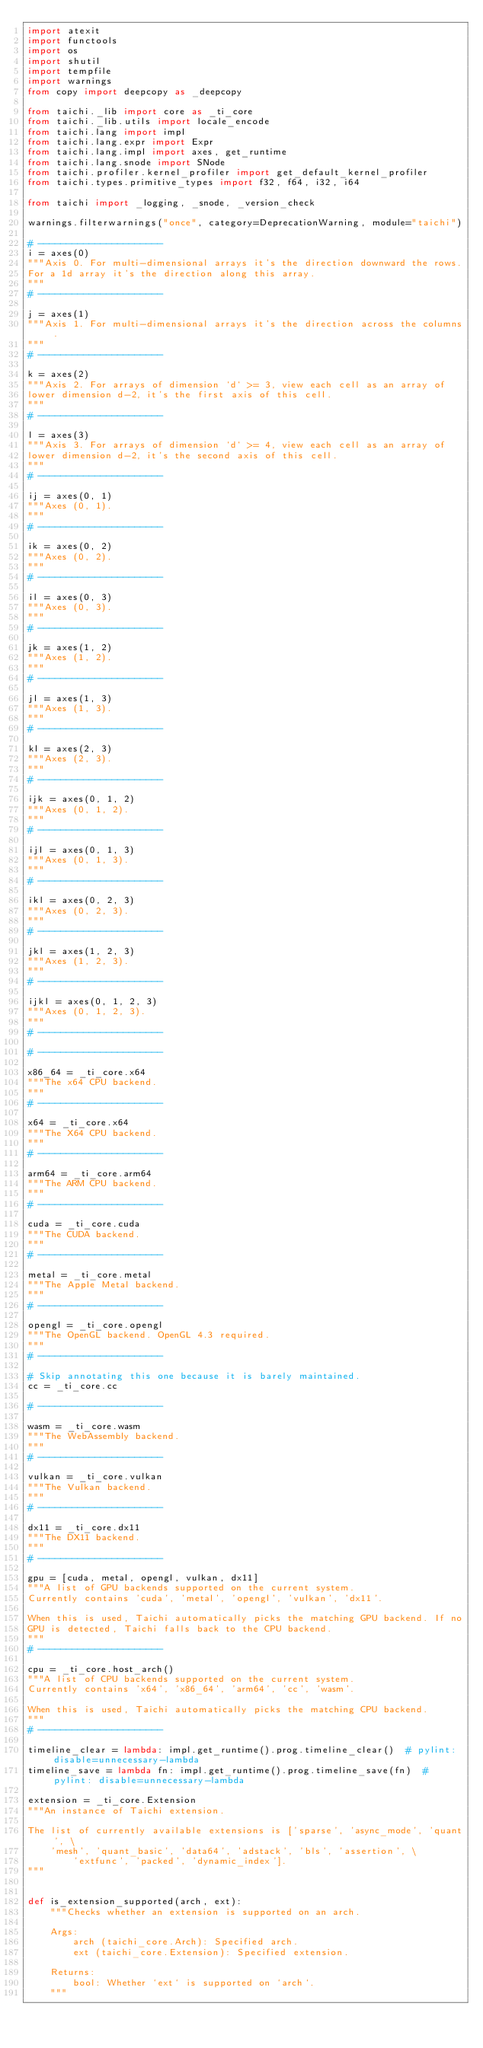<code> <loc_0><loc_0><loc_500><loc_500><_Python_>import atexit
import functools
import os
import shutil
import tempfile
import warnings
from copy import deepcopy as _deepcopy

from taichi._lib import core as _ti_core
from taichi._lib.utils import locale_encode
from taichi.lang import impl
from taichi.lang.expr import Expr
from taichi.lang.impl import axes, get_runtime
from taichi.lang.snode import SNode
from taichi.profiler.kernel_profiler import get_default_kernel_profiler
from taichi.types.primitive_types import f32, f64, i32, i64

from taichi import _logging, _snode, _version_check

warnings.filterwarnings("once", category=DeprecationWarning, module="taichi")

# ----------------------
i = axes(0)
"""Axis 0. For multi-dimensional arrays it's the direction downward the rows.
For a 1d array it's the direction along this array.
"""
# ----------------------

j = axes(1)
"""Axis 1. For multi-dimensional arrays it's the direction across the columns.
"""
# ----------------------

k = axes(2)
"""Axis 2. For arrays of dimension `d` >= 3, view each cell as an array of
lower dimension d-2, it's the first axis of this cell.
"""
# ----------------------

l = axes(3)
"""Axis 3. For arrays of dimension `d` >= 4, view each cell as an array of
lower dimension d-2, it's the second axis of this cell.
"""
# ----------------------

ij = axes(0, 1)
"""Axes (0, 1).
"""
# ----------------------

ik = axes(0, 2)
"""Axes (0, 2).
"""
# ----------------------

il = axes(0, 3)
"""Axes (0, 3).
"""
# ----------------------

jk = axes(1, 2)
"""Axes (1, 2).
"""
# ----------------------

jl = axes(1, 3)
"""Axes (1, 3).
"""
# ----------------------

kl = axes(2, 3)
"""Axes (2, 3).
"""
# ----------------------

ijk = axes(0, 1, 2)
"""Axes (0, 1, 2).
"""
# ----------------------

ijl = axes(0, 1, 3)
"""Axes (0, 1, 3).
"""
# ----------------------

ikl = axes(0, 2, 3)
"""Axes (0, 2, 3).
"""
# ----------------------

jkl = axes(1, 2, 3)
"""Axes (1, 2, 3).
"""
# ----------------------

ijkl = axes(0, 1, 2, 3)
"""Axes (0, 1, 2, 3).
"""
# ----------------------

# ----------------------

x86_64 = _ti_core.x64
"""The x64 CPU backend.
"""
# ----------------------

x64 = _ti_core.x64
"""The X64 CPU backend.
"""
# ----------------------

arm64 = _ti_core.arm64
"""The ARM CPU backend.
"""
# ----------------------

cuda = _ti_core.cuda
"""The CUDA backend.
"""
# ----------------------

metal = _ti_core.metal
"""The Apple Metal backend.
"""
# ----------------------

opengl = _ti_core.opengl
"""The OpenGL backend. OpenGL 4.3 required.
"""
# ----------------------

# Skip annotating this one because it is barely maintained.
cc = _ti_core.cc

# ----------------------

wasm = _ti_core.wasm
"""The WebAssembly backend.
"""
# ----------------------

vulkan = _ti_core.vulkan
"""The Vulkan backend.
"""
# ----------------------

dx11 = _ti_core.dx11
"""The DX11 backend.
"""
# ----------------------

gpu = [cuda, metal, opengl, vulkan, dx11]
"""A list of GPU backends supported on the current system.
Currently contains 'cuda', 'metal', 'opengl', 'vulkan', 'dx11'.

When this is used, Taichi automatically picks the matching GPU backend. If no
GPU is detected, Taichi falls back to the CPU backend.
"""
# ----------------------

cpu = _ti_core.host_arch()
"""A list of CPU backends supported on the current system.
Currently contains 'x64', 'x86_64', 'arm64', 'cc', 'wasm'.

When this is used, Taichi automatically picks the matching CPU backend.
"""
# ----------------------

timeline_clear = lambda: impl.get_runtime().prog.timeline_clear()  # pylint: disable=unnecessary-lambda
timeline_save = lambda fn: impl.get_runtime().prog.timeline_save(fn)  # pylint: disable=unnecessary-lambda

extension = _ti_core.Extension
"""An instance of Taichi extension.

The list of currently available extensions is ['sparse', 'async_mode', 'quant', \
    'mesh', 'quant_basic', 'data64', 'adstack', 'bls', 'assertion', \
        'extfunc', 'packed', 'dynamic_index'].
"""


def is_extension_supported(arch, ext):
    """Checks whether an extension is supported on an arch.

    Args:
        arch (taichi_core.Arch): Specified arch.
        ext (taichi_core.Extension): Specified extension.

    Returns:
        bool: Whether `ext` is supported on `arch`.
    """</code> 